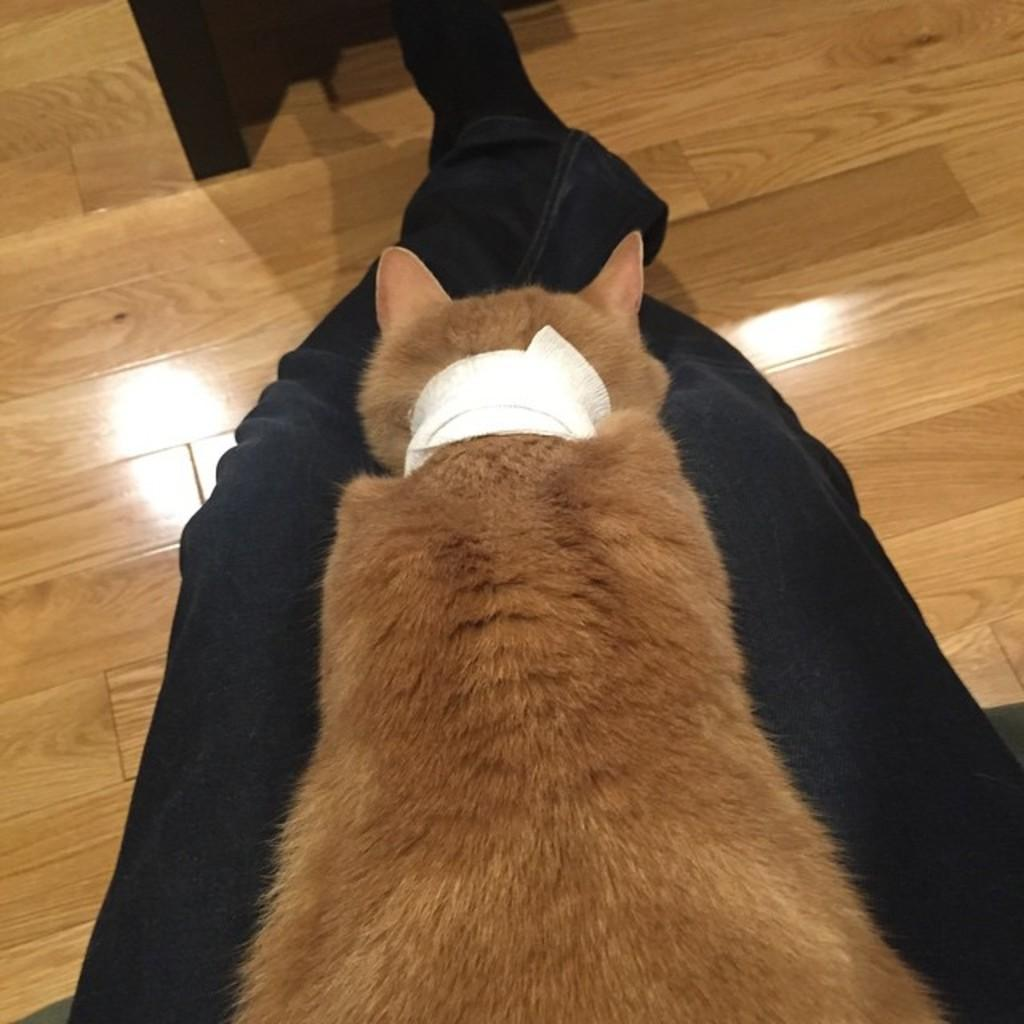What type of animal is in the image? There is a brown color animal in the image. Where is the animal located in the image? The animal is on the legs of a person. What type of flooring is visible in the image? There is a wooden floor visible in the image. What caused the egg to burn in the image? There is no egg or any indication of burning in the image. 